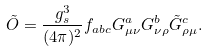<formula> <loc_0><loc_0><loc_500><loc_500>\tilde { O } = { \frac { g _ { s } ^ { 3 } } { ( 4 \pi ) ^ { 2 } } } f _ { a b c } G _ { \mu \nu } ^ { a } G _ { \nu \rho } ^ { b } \tilde { G } _ { \rho \mu } ^ { c } .</formula> 